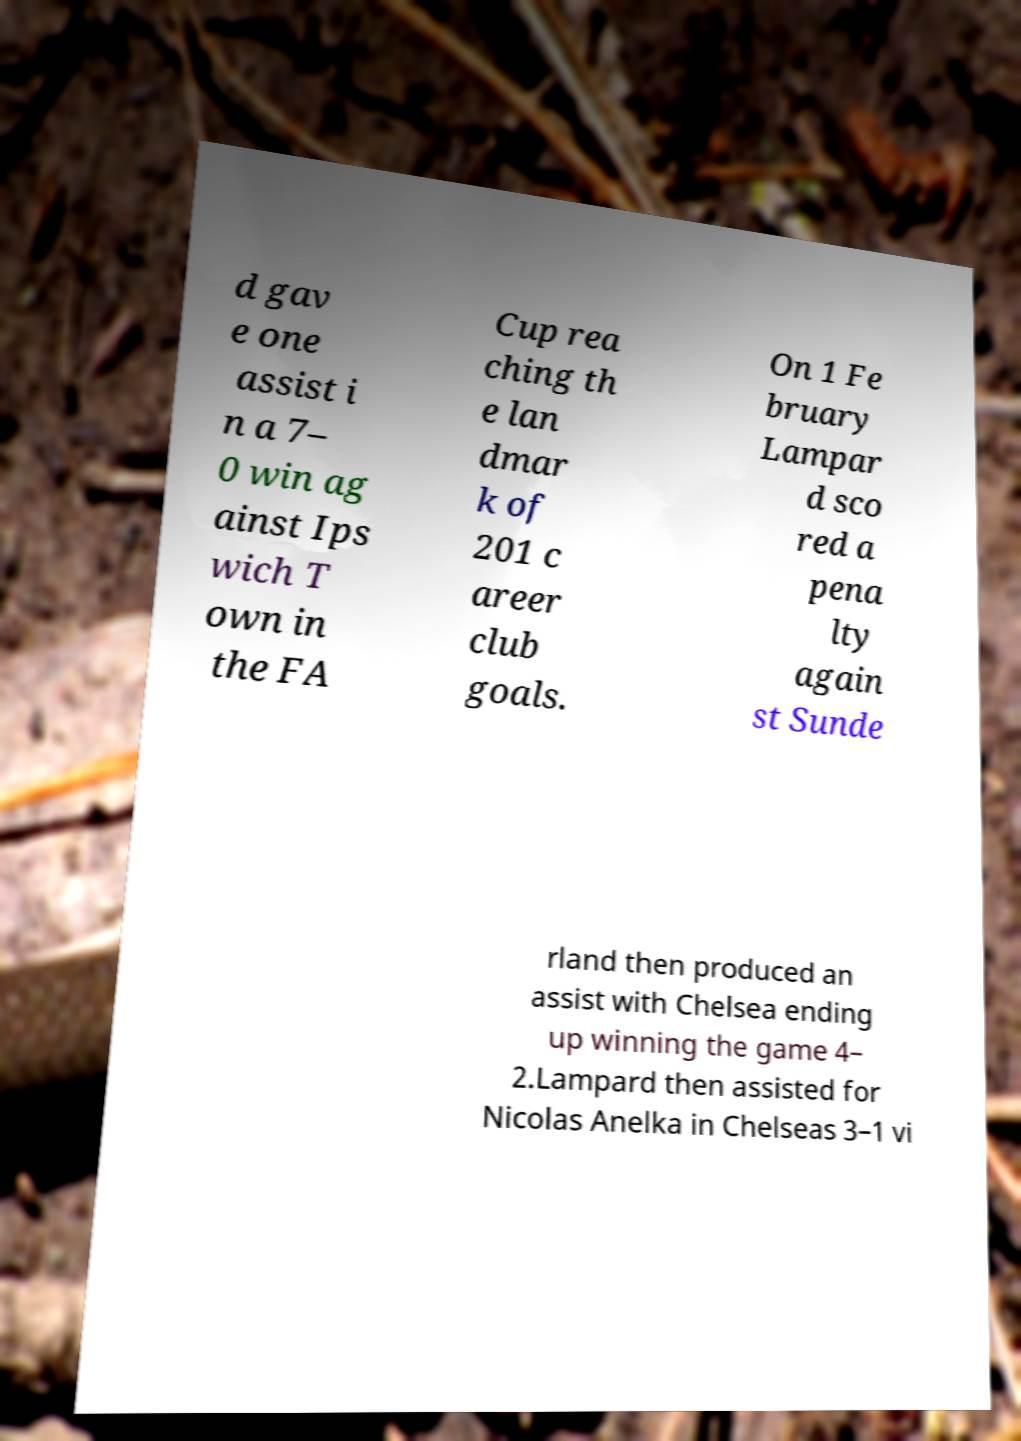What messages or text are displayed in this image? I need them in a readable, typed format. d gav e one assist i n a 7– 0 win ag ainst Ips wich T own in the FA Cup rea ching th e lan dmar k of 201 c areer club goals. On 1 Fe bruary Lampar d sco red a pena lty again st Sunde rland then produced an assist with Chelsea ending up winning the game 4– 2.Lampard then assisted for Nicolas Anelka in Chelseas 3–1 vi 